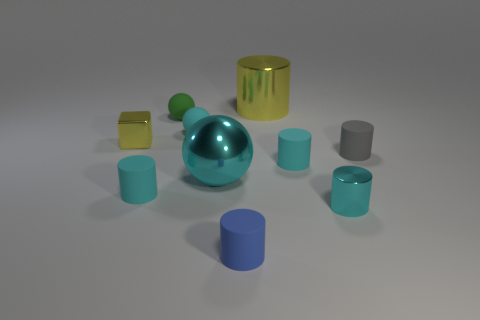Is the tiny green thing the same shape as the tiny yellow object?
Ensure brevity in your answer.  No. What is the size of the cylinder that is the same color as the cube?
Offer a very short reply. Large. How many tiny cyan matte balls are in front of the small metal thing that is right of the cube?
Make the answer very short. 0. How many things are both left of the small cyan shiny cylinder and behind the cyan metallic cylinder?
Provide a succinct answer. 7. How many things are either cubes or rubber cylinders that are behind the large sphere?
Offer a very short reply. 3. The cyan sphere that is the same material as the small block is what size?
Provide a succinct answer. Large. There is a cyan matte object that is on the right side of the small blue matte cylinder on the right side of the large cyan shiny object; what is its shape?
Your answer should be compact. Cylinder. What number of blue things are rubber balls or matte objects?
Your answer should be compact. 1. There is a metal object that is behind the cyan ball behind the tiny yellow object; are there any green spheres that are on the right side of it?
Your response must be concise. No. There is a tiny metallic thing that is the same color as the large metal ball; what shape is it?
Give a very brief answer. Cylinder. 